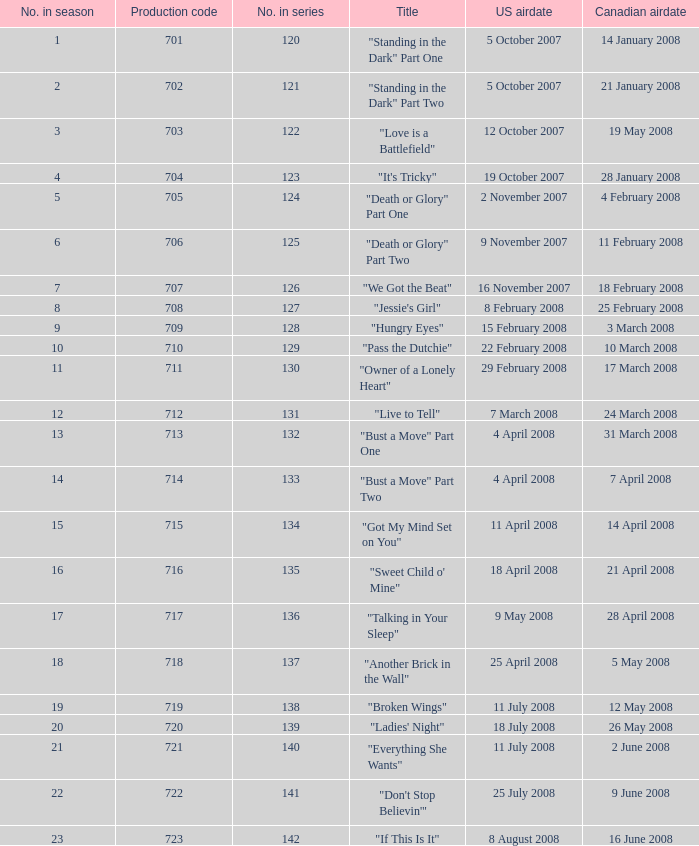The U.S. airdate of 4 april 2008 had a production code of what? 714.0. 